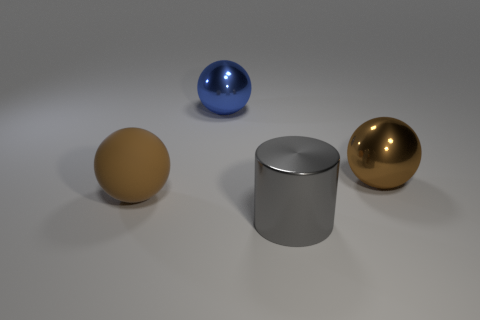The big rubber sphere has what color?
Keep it short and to the point. Brown. How many large balls are the same color as the large rubber thing?
Make the answer very short. 1. There is a cylinder that is the same size as the blue metallic sphere; what is it made of?
Provide a short and direct response. Metal. Is there a blue shiny sphere that is behind the brown sphere behind the big rubber thing?
Your answer should be compact. Yes. What number of other things are there of the same color as the metal cylinder?
Your answer should be very brief. 0. What size is the rubber thing?
Provide a succinct answer. Large. Is there a red matte ball?
Offer a very short reply. No. Are there more big brown rubber spheres that are to the right of the big blue metal thing than big brown spheres that are right of the big cylinder?
Offer a very short reply. No. What is the ball that is in front of the big blue metal ball and left of the gray metal thing made of?
Your response must be concise. Rubber. Does the rubber object have the same shape as the blue object?
Give a very brief answer. Yes. 